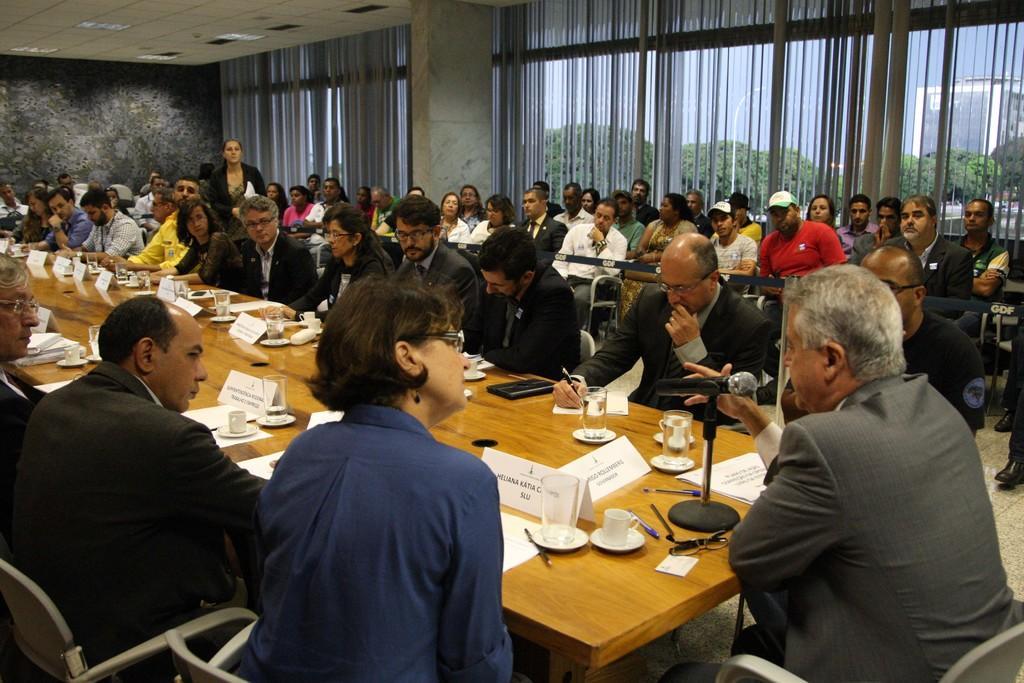How would you summarize this image in a sentence or two? The picture is taken inside a conference and labels, notebooks, glasses are on top of it. A guy is sitting to the right side of the image has a mic in front of him. In the background we observe many people spectating and there is a curtain in the background. 